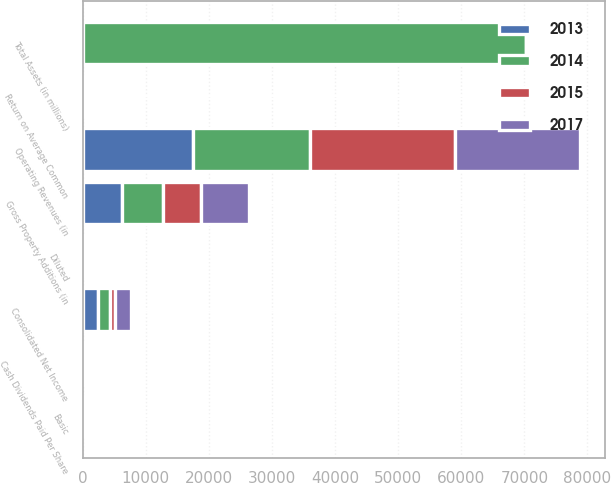<chart> <loc_0><loc_0><loc_500><loc_500><stacked_bar_chart><ecel><fcel>Operating Revenues (in<fcel>Total Assets (in millions)<fcel>Gross Property Additions (in<fcel>Return on Average Common<fcel>Cash Dividends Paid Per Share<fcel>Consolidated Net Income<fcel>Basic<fcel>Diluted<nl><fcel>2015<fcel>23031<fcel>10.8<fcel>5984<fcel>3.44<fcel>2.3<fcel>842<fcel>0.84<fcel>0.84<nl><fcel>2017<fcel>19896<fcel>10.8<fcel>7624<fcel>10.8<fcel>2.22<fcel>2448<fcel>2.57<fcel>2.55<nl><fcel>2013<fcel>17489<fcel>10.8<fcel>6169<fcel>11.68<fcel>2.15<fcel>2367<fcel>2.6<fcel>2.59<nl><fcel>2014<fcel>18467<fcel>70233<fcel>6522<fcel>10.08<fcel>2.08<fcel>1963<fcel>2.19<fcel>2.18<nl></chart> 